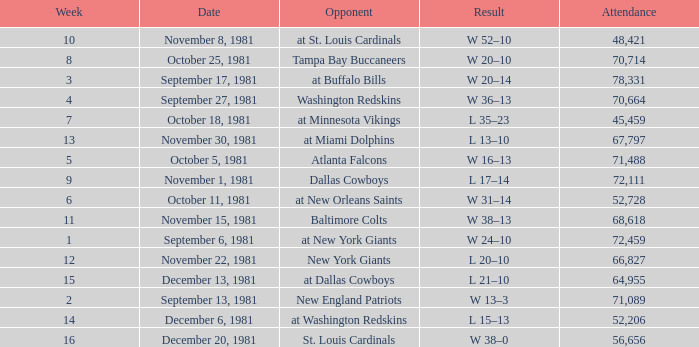What is the Attendance, when the Opponent is the Tampa Bay Buccaneers? 70714.0. Write the full table. {'header': ['Week', 'Date', 'Opponent', 'Result', 'Attendance'], 'rows': [['10', 'November 8, 1981', 'at St. Louis Cardinals', 'W 52–10', '48,421'], ['8', 'October 25, 1981', 'Tampa Bay Buccaneers', 'W 20–10', '70,714'], ['3', 'September 17, 1981', 'at Buffalo Bills', 'W 20–14', '78,331'], ['4', 'September 27, 1981', 'Washington Redskins', 'W 36–13', '70,664'], ['7', 'October 18, 1981', 'at Minnesota Vikings', 'L 35–23', '45,459'], ['13', 'November 30, 1981', 'at Miami Dolphins', 'L 13–10', '67,797'], ['5', 'October 5, 1981', 'Atlanta Falcons', 'W 16–13', '71,488'], ['9', 'November 1, 1981', 'Dallas Cowboys', 'L 17–14', '72,111'], ['6', 'October 11, 1981', 'at New Orleans Saints', 'W 31–14', '52,728'], ['11', 'November 15, 1981', 'Baltimore Colts', 'W 38–13', '68,618'], ['1', 'September 6, 1981', 'at New York Giants', 'W 24–10', '72,459'], ['12', 'November 22, 1981', 'New York Giants', 'L 20–10', '66,827'], ['15', 'December 13, 1981', 'at Dallas Cowboys', 'L 21–10', '64,955'], ['2', 'September 13, 1981', 'New England Patriots', 'W 13–3', '71,089'], ['14', 'December 6, 1981', 'at Washington Redskins', 'L 15–13', '52,206'], ['16', 'December 20, 1981', 'St. Louis Cardinals', 'W 38–0', '56,656']]} 